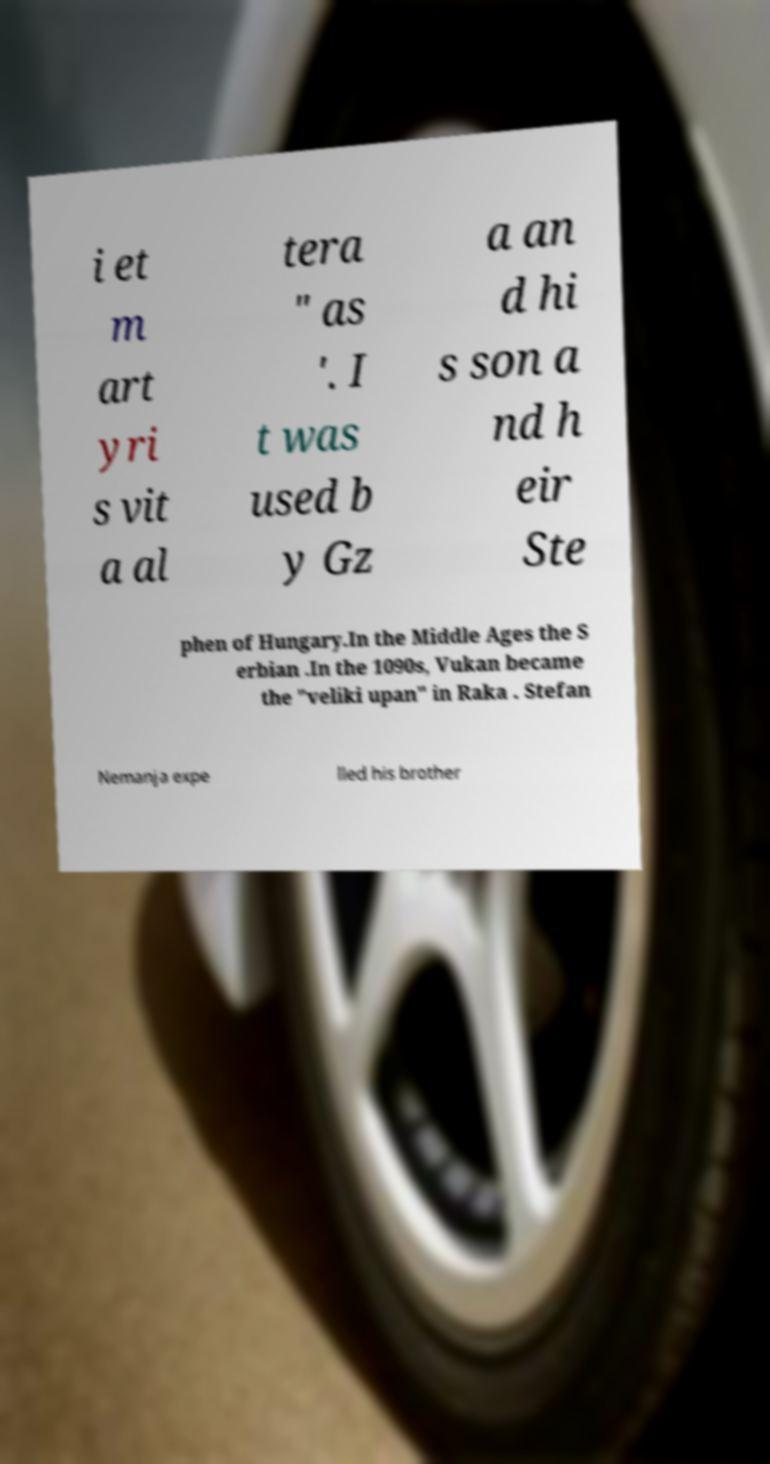There's text embedded in this image that I need extracted. Can you transcribe it verbatim? i et m art yri s vit a al tera " as '. I t was used b y Gz a an d hi s son a nd h eir Ste phen of Hungary.In the Middle Ages the S erbian .In the 1090s, Vukan became the "veliki upan" in Raka . Stefan Nemanja expe lled his brother 